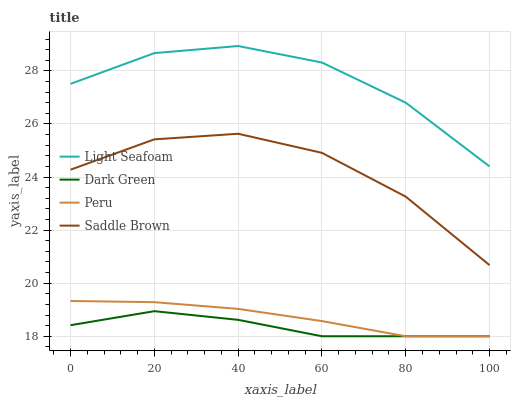Does Dark Green have the minimum area under the curve?
Answer yes or no. Yes. Does Light Seafoam have the maximum area under the curve?
Answer yes or no. Yes. Does Saddle Brown have the minimum area under the curve?
Answer yes or no. No. Does Saddle Brown have the maximum area under the curve?
Answer yes or no. No. Is Peru the smoothest?
Answer yes or no. Yes. Is Saddle Brown the roughest?
Answer yes or no. Yes. Is Saddle Brown the smoothest?
Answer yes or no. No. Is Peru the roughest?
Answer yes or no. No. Does Saddle Brown have the lowest value?
Answer yes or no. No. Does Light Seafoam have the highest value?
Answer yes or no. Yes. Does Saddle Brown have the highest value?
Answer yes or no. No. Is Peru less than Light Seafoam?
Answer yes or no. Yes. Is Light Seafoam greater than Dark Green?
Answer yes or no. Yes. Does Peru intersect Dark Green?
Answer yes or no. Yes. Is Peru less than Dark Green?
Answer yes or no. No. Is Peru greater than Dark Green?
Answer yes or no. No. Does Peru intersect Light Seafoam?
Answer yes or no. No. 